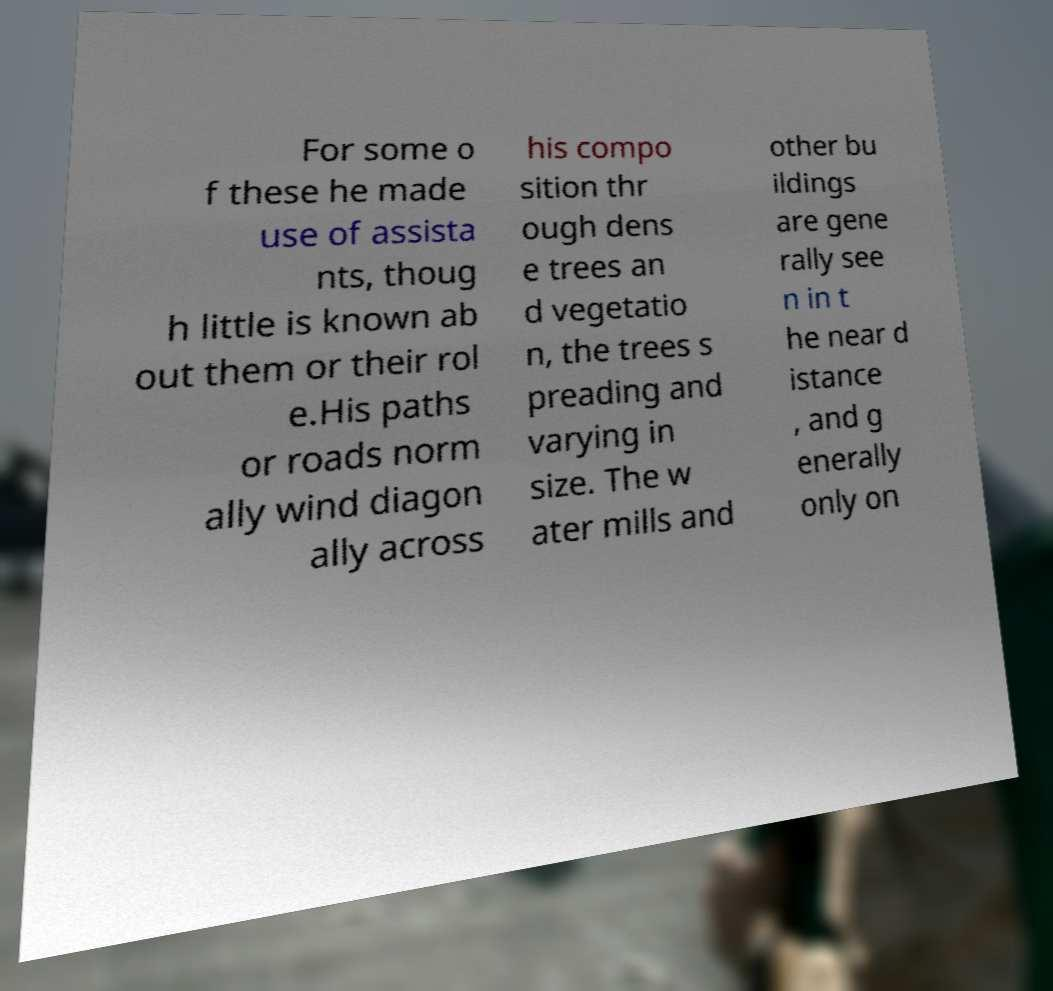There's text embedded in this image that I need extracted. Can you transcribe it verbatim? For some o f these he made use of assista nts, thoug h little is known ab out them or their rol e.His paths or roads norm ally wind diagon ally across his compo sition thr ough dens e trees an d vegetatio n, the trees s preading and varying in size. The w ater mills and other bu ildings are gene rally see n in t he near d istance , and g enerally only on 